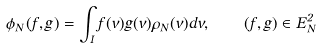<formula> <loc_0><loc_0><loc_500><loc_500>\phi _ { N } ( f , g ) = \int _ { I } f ( v ) g ( v ) \rho _ { N } ( v ) d v , \quad ( f , g ) \in E _ { N } ^ { 2 }</formula> 